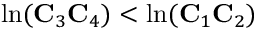Convert formula to latex. <formula><loc_0><loc_0><loc_500><loc_500>\ln ( C _ { 3 } C _ { 4 } ) < \ln ( C _ { 1 } C _ { 2 } )</formula> 